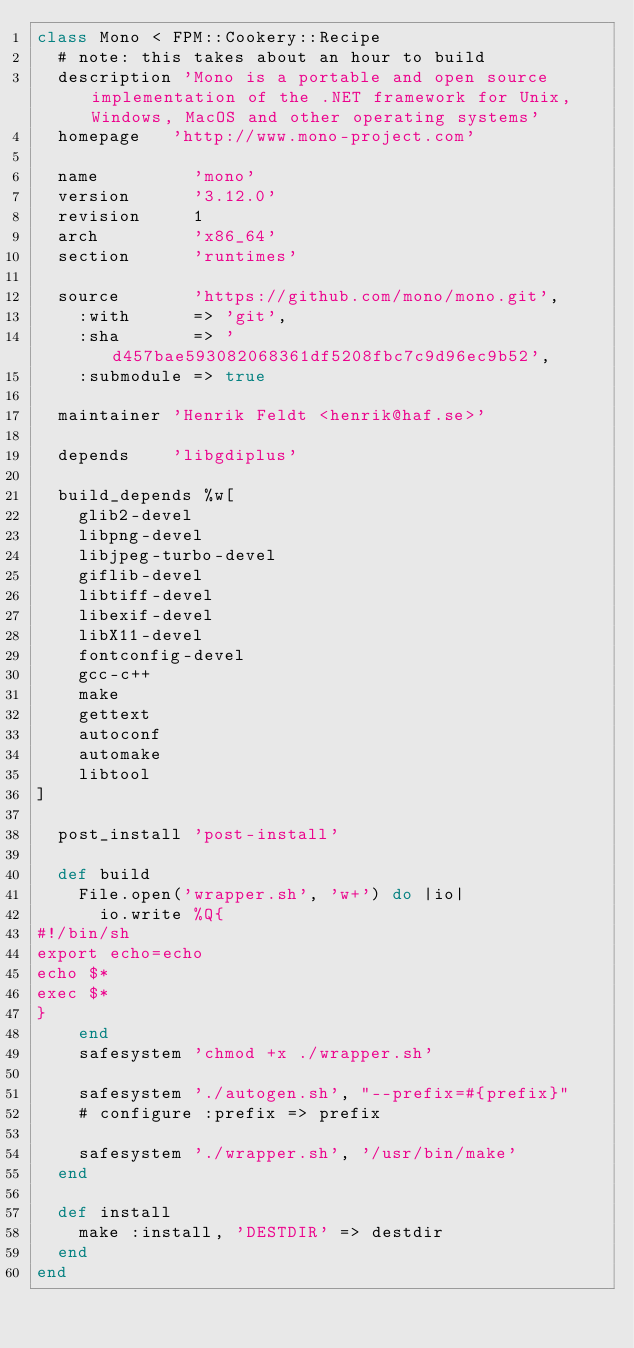<code> <loc_0><loc_0><loc_500><loc_500><_Ruby_>class Mono < FPM::Cookery::Recipe
  # note: this takes about an hour to build
  description 'Mono is a portable and open source implementation of the .NET framework for Unix, Windows, MacOS and other operating systems'
  homepage   'http://www.mono-project.com'

  name         'mono'
  version      '3.12.0'
  revision     1
  arch         'x86_64'
  section      'runtimes'

  source       'https://github.com/mono/mono.git',
    :with      => 'git',
    :sha       => 'd457bae593082068361df5208fbc7c9d96ec9b52',
    :submodule => true

  maintainer 'Henrik Feldt <henrik@haf.se>'

  depends    'libgdiplus'

  build_depends %w[
    glib2-devel
    libpng-devel
    libjpeg-turbo-devel
    giflib-devel
    libtiff-devel
    libexif-devel
    libX11-devel
    fontconfig-devel
    gcc-c++
    make
    gettext
    autoconf
    automake
    libtool
]

  post_install 'post-install'

  def build
    File.open('wrapper.sh', 'w+') do |io|
      io.write %Q{
#!/bin/sh
export echo=echo
echo $*
exec $*
}
    end
    safesystem 'chmod +x ./wrapper.sh'

    safesystem './autogen.sh', "--prefix=#{prefix}"
    # configure :prefix => prefix

    safesystem './wrapper.sh', '/usr/bin/make'
  end

  def install
    make :install, 'DESTDIR' => destdir
  end
end
</code> 